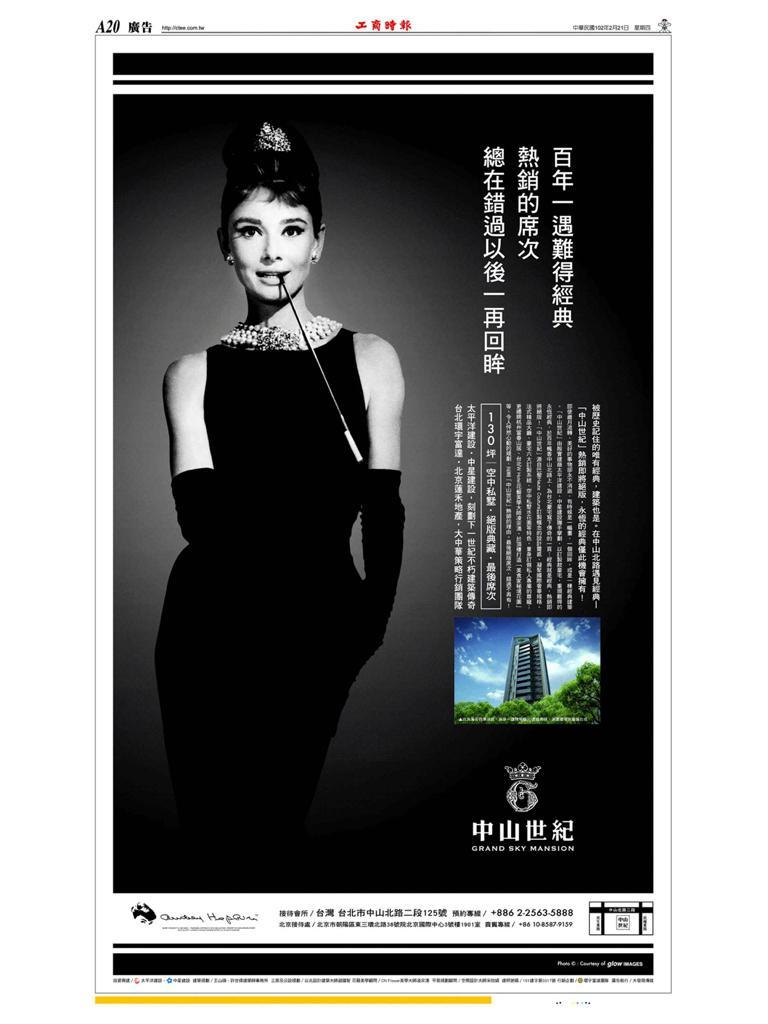What is the main object in the image? There is a poster in the image. What can be found on the poster? The poster contains words, a logo, pictures of a woman, treats, a building, and the sky. What is the color of the background in the image? The background of the image is dark. How does the temper of the waves affect the blade in the image? There are no waves or blades present in the image; it features a poster with various elements. 